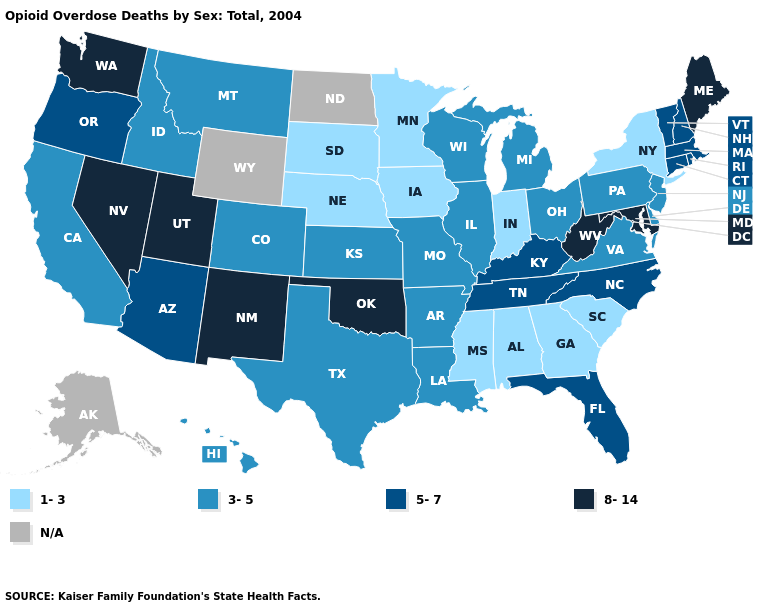Which states have the lowest value in the USA?
Be succinct. Alabama, Georgia, Indiana, Iowa, Minnesota, Mississippi, Nebraska, New York, South Carolina, South Dakota. Among the states that border Illinois , which have the highest value?
Be succinct. Kentucky. Does Arkansas have the highest value in the USA?
Short answer required. No. Which states hav the highest value in the West?
Answer briefly. Nevada, New Mexico, Utah, Washington. Does New Mexico have the highest value in the West?
Keep it brief. Yes. Does Virginia have the highest value in the USA?
Concise answer only. No. Does Minnesota have the lowest value in the USA?
Be succinct. Yes. Name the states that have a value in the range 8-14?
Short answer required. Maine, Maryland, Nevada, New Mexico, Oklahoma, Utah, Washington, West Virginia. Which states hav the highest value in the MidWest?
Give a very brief answer. Illinois, Kansas, Michigan, Missouri, Ohio, Wisconsin. Name the states that have a value in the range 5-7?
Quick response, please. Arizona, Connecticut, Florida, Kentucky, Massachusetts, New Hampshire, North Carolina, Oregon, Rhode Island, Tennessee, Vermont. Name the states that have a value in the range 3-5?
Concise answer only. Arkansas, California, Colorado, Delaware, Hawaii, Idaho, Illinois, Kansas, Louisiana, Michigan, Missouri, Montana, New Jersey, Ohio, Pennsylvania, Texas, Virginia, Wisconsin. Among the states that border Louisiana , which have the lowest value?
Give a very brief answer. Mississippi. Does Nevada have the lowest value in the USA?
Quick response, please. No. Among the states that border Rhode Island , which have the lowest value?
Short answer required. Connecticut, Massachusetts. Name the states that have a value in the range 8-14?
Keep it brief. Maine, Maryland, Nevada, New Mexico, Oklahoma, Utah, Washington, West Virginia. 